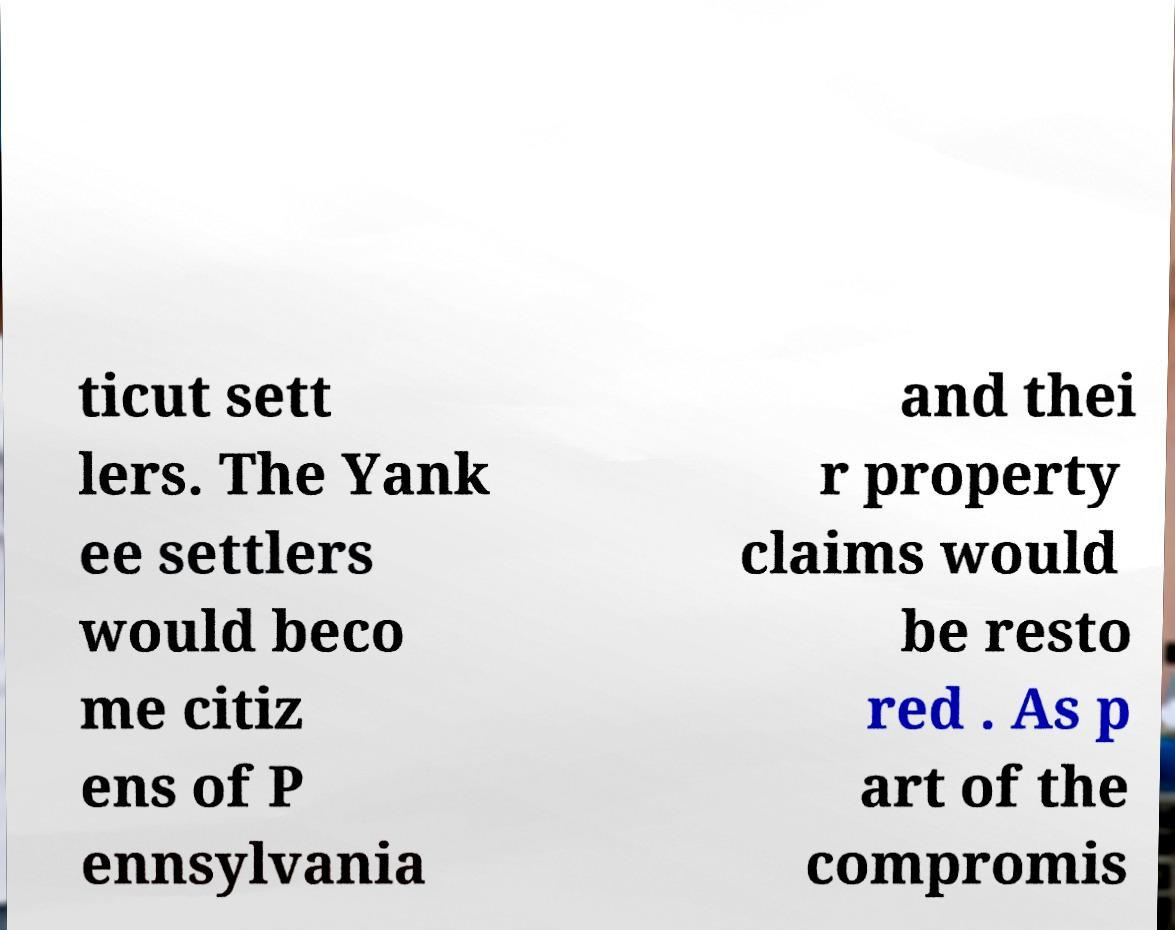Can you read and provide the text displayed in the image?This photo seems to have some interesting text. Can you extract and type it out for me? ticut sett lers. The Yank ee settlers would beco me citiz ens of P ennsylvania and thei r property claims would be resto red . As p art of the compromis 